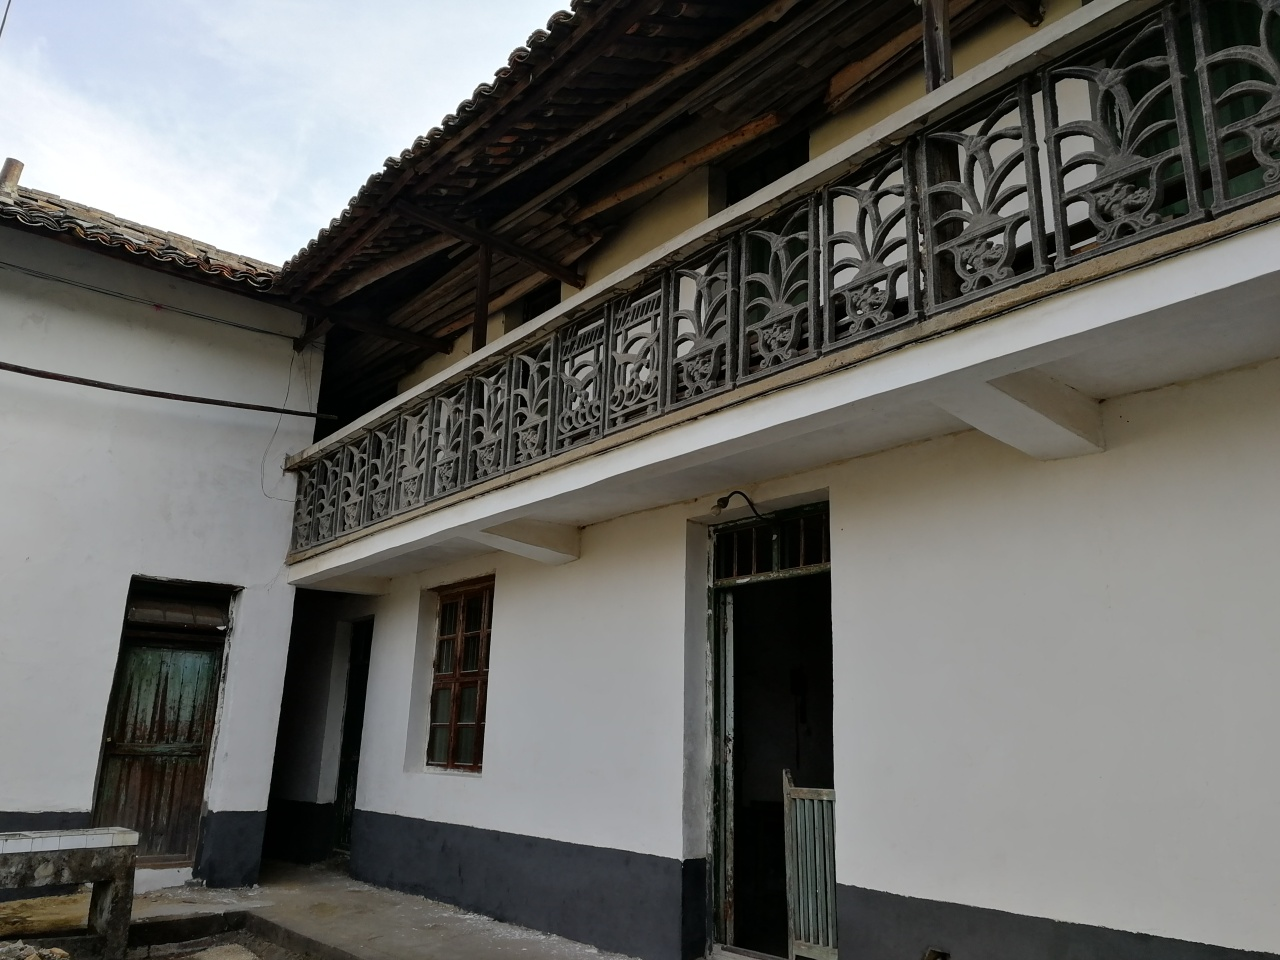What might be the cultural significance of this type of balcony railing design? Balcony railings such as this one, with detailed metalwork, are often reflective of local craftsmanship and cultural influences. Such intricate designs can indicate the importance of aesthetic detail in the region's architecture and may also serve as a status symbol, showcasing the homeowner's resources and taste. 